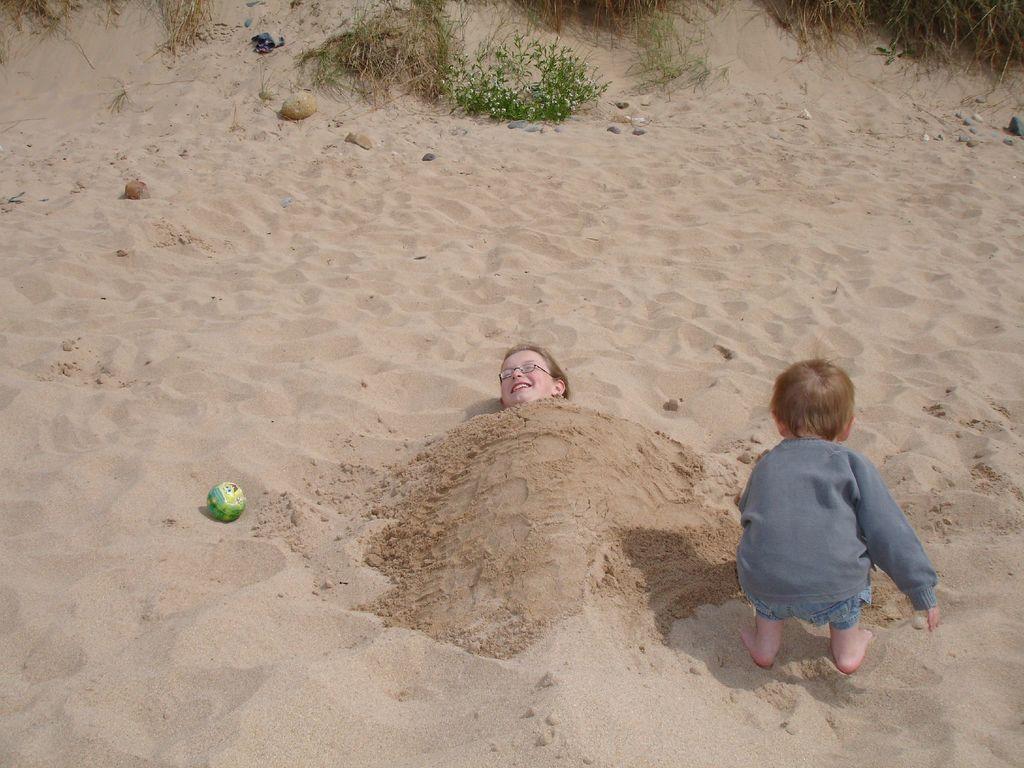Describe this image in one or two sentences. In this picture there is a girl who is wearing spectacle and she is smiling. She is lying on the sand. On her body I can see the sand. On the right there is a boy who is standing near to her. At the top I can see the grass and plants. On the top right corner I can see some small stones. 